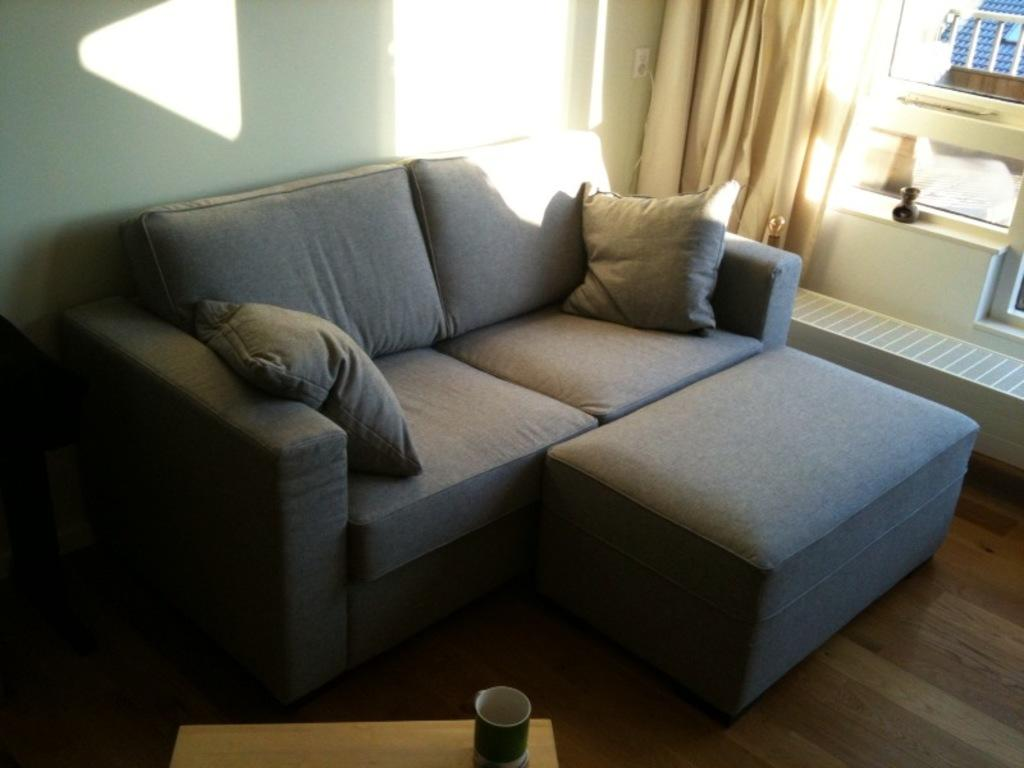What type of furniture is in the image? There is a couch in the image. What is located in front of the couch? There is a table in front of the couch. What can be seen on the table? There is a cup on the table. What is visible in the background of the image? There is a curtain in the background of the image. What type of engine can be seen powering the couch in the image? There is no engine present in the image, and the couch is not powered by any engine. 